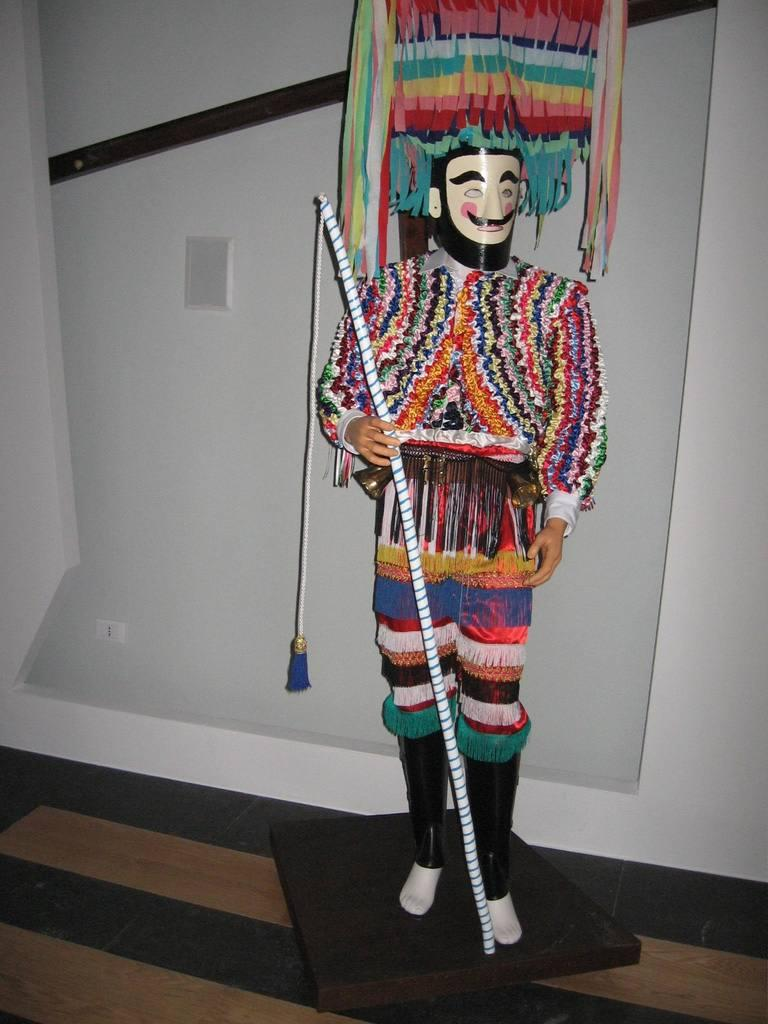What is the main subject in the image? There is a mannequin in the image. What is the mannequin wearing? The mannequin is dressed in a costume. What is the mannequin holding? The mannequin is holding a stick. What can be seen in the background of the image? There is a wall in the background of the image. What is visible at the bottom of the image? The floor is visible at the bottom of the image. What type of theory is the mannequin discussing with the organization in the image? There is no discussion or organization present in the image; it features a mannequin dressed in a costume and holding a stick. 